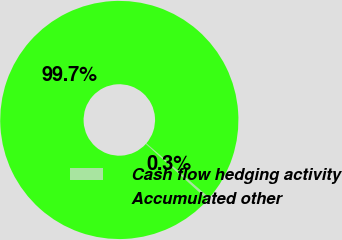Convert chart. <chart><loc_0><loc_0><loc_500><loc_500><pie_chart><fcel>Cash flow hedging activity<fcel>Accumulated other<nl><fcel>0.34%<fcel>99.66%<nl></chart> 